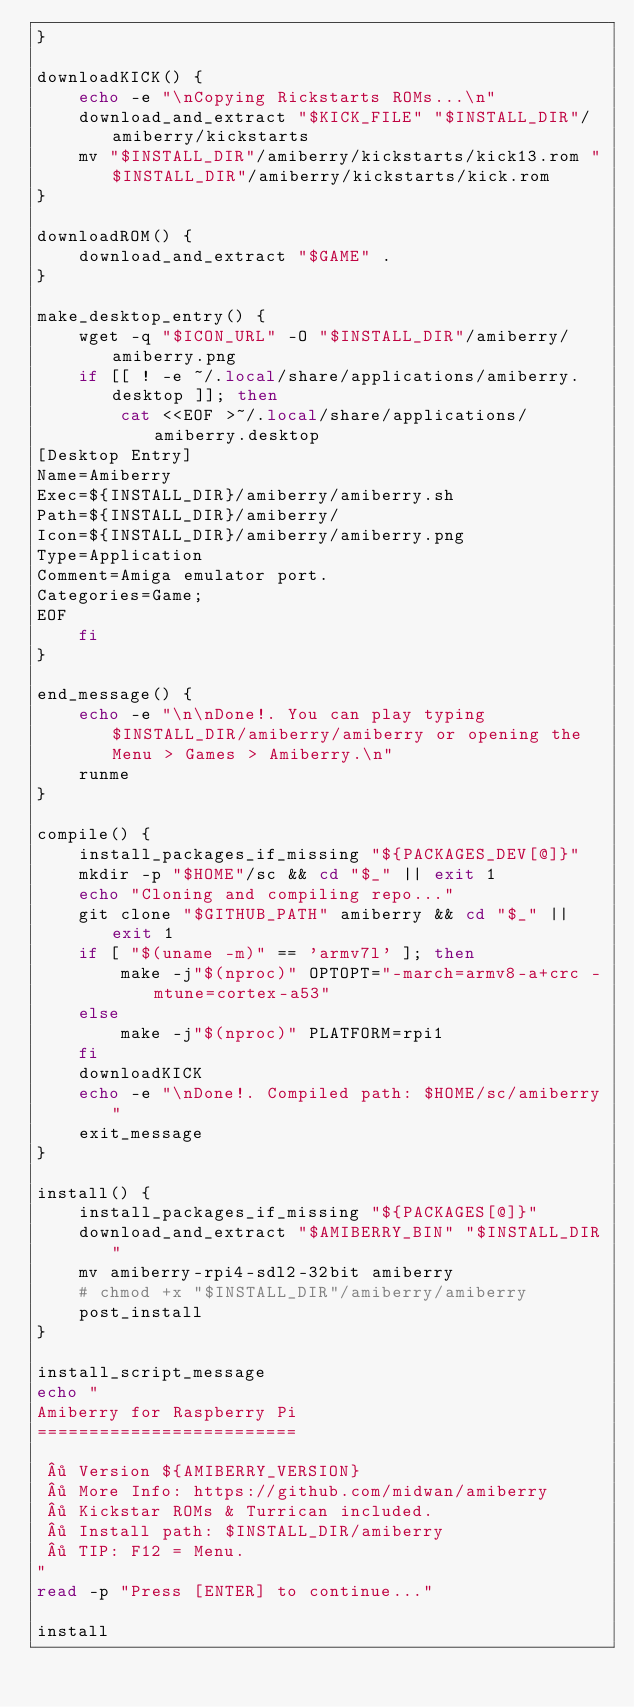Convert code to text. <code><loc_0><loc_0><loc_500><loc_500><_Bash_>}

downloadKICK() {
    echo -e "\nCopying Rickstarts ROMs...\n"
    download_and_extract "$KICK_FILE" "$INSTALL_DIR"/amiberry/kickstarts
    mv "$INSTALL_DIR"/amiberry/kickstarts/kick13.rom "$INSTALL_DIR"/amiberry/kickstarts/kick.rom
}

downloadROM() {
    download_and_extract "$GAME" .
}

make_desktop_entry() {
    wget -q "$ICON_URL" -O "$INSTALL_DIR"/amiberry/amiberry.png
    if [[ ! -e ~/.local/share/applications/amiberry.desktop ]]; then
        cat <<EOF >~/.local/share/applications/amiberry.desktop
[Desktop Entry]
Name=Amiberry
Exec=${INSTALL_DIR}/amiberry/amiberry.sh
Path=${INSTALL_DIR}/amiberry/
Icon=${INSTALL_DIR}/amiberry/amiberry.png
Type=Application
Comment=Amiga emulator port.
Categories=Game;
EOF
    fi
}

end_message() {
    echo -e "\n\nDone!. You can play typing $INSTALL_DIR/amiberry/amiberry or opening the Menu > Games > Amiberry.\n"
    runme
}

compile() {
    install_packages_if_missing "${PACKAGES_DEV[@]}"
    mkdir -p "$HOME"/sc && cd "$_" || exit 1
    echo "Cloning and compiling repo..."
    git clone "$GITHUB_PATH" amiberry && cd "$_" || exit 1
    if [ "$(uname -m)" == 'armv7l' ]; then
        make -j"$(nproc)" OPTOPT="-march=armv8-a+crc -mtune=cortex-a53"
    else
        make -j"$(nproc)" PLATFORM=rpi1
    fi
    downloadKICK
    echo -e "\nDone!. Compiled path: $HOME/sc/amiberry"
    exit_message
}

install() {
    install_packages_if_missing "${PACKAGES[@]}"
    download_and_extract "$AMIBERRY_BIN" "$INSTALL_DIR"
    mv amiberry-rpi4-sdl2-32bit amiberry
    # chmod +x "$INSTALL_DIR"/amiberry/amiberry
    post_install
}

install_script_message
echo "
Amiberry for Raspberry Pi
=========================

 · Version ${AMIBERRY_VERSION}
 · More Info: https://github.com/midwan/amiberry
 · Kickstar ROMs & Turrican included.
 · Install path: $INSTALL_DIR/amiberry
 · TIP: F12 = Menu.
"
read -p "Press [ENTER] to continue..."

install
</code> 